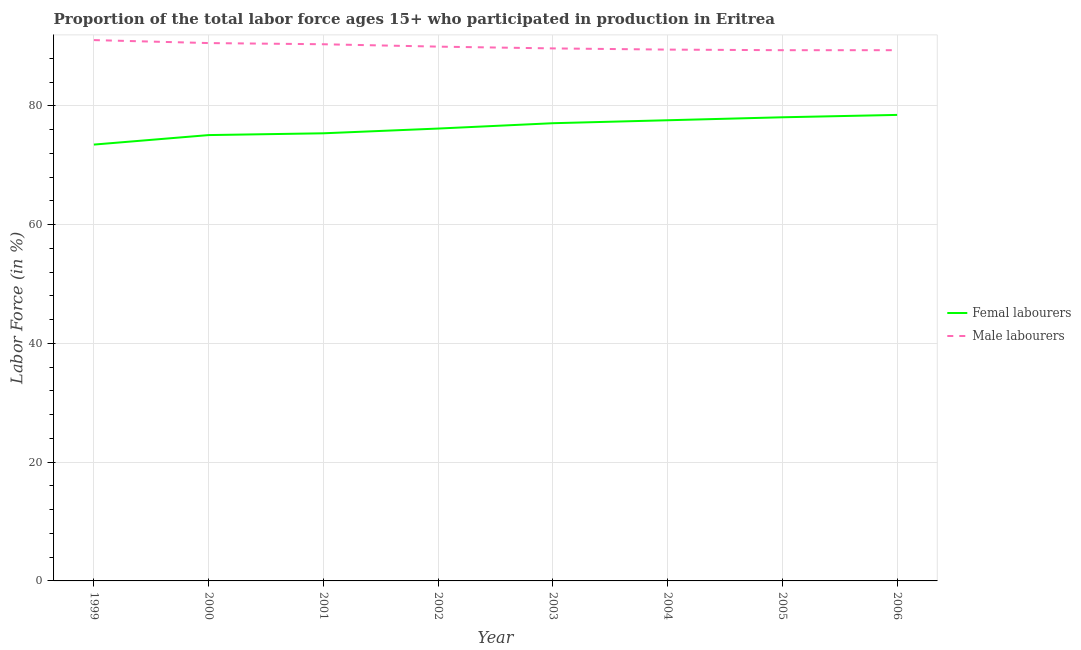How many different coloured lines are there?
Your response must be concise. 2. Does the line corresponding to percentage of female labor force intersect with the line corresponding to percentage of male labour force?
Provide a short and direct response. No. Is the number of lines equal to the number of legend labels?
Give a very brief answer. Yes. What is the percentage of female labor force in 2000?
Provide a short and direct response. 75.1. Across all years, what is the maximum percentage of female labor force?
Offer a very short reply. 78.5. Across all years, what is the minimum percentage of male labour force?
Provide a succinct answer. 89.4. What is the total percentage of male labour force in the graph?
Provide a succinct answer. 720.1. What is the difference between the percentage of female labor force in 2000 and that in 2001?
Provide a succinct answer. -0.3. What is the difference between the percentage of female labor force in 2004 and the percentage of male labour force in 2000?
Keep it short and to the point. -13. What is the average percentage of male labour force per year?
Keep it short and to the point. 90.01. In the year 2003, what is the difference between the percentage of female labor force and percentage of male labour force?
Give a very brief answer. -12.6. In how many years, is the percentage of male labour force greater than 80 %?
Make the answer very short. 8. What is the ratio of the percentage of female labor force in 1999 to that in 2000?
Provide a succinct answer. 0.98. Is the difference between the percentage of male labour force in 2001 and 2002 greater than the difference between the percentage of female labor force in 2001 and 2002?
Your response must be concise. Yes. What is the difference between the highest and the second highest percentage of female labor force?
Ensure brevity in your answer.  0.4. In how many years, is the percentage of female labor force greater than the average percentage of female labor force taken over all years?
Offer a terse response. 4. Is the sum of the percentage of male labour force in 1999 and 2006 greater than the maximum percentage of female labor force across all years?
Give a very brief answer. Yes. Is the percentage of male labour force strictly greater than the percentage of female labor force over the years?
Make the answer very short. Yes. How many years are there in the graph?
Offer a very short reply. 8. What is the difference between two consecutive major ticks on the Y-axis?
Provide a short and direct response. 20. Where does the legend appear in the graph?
Provide a succinct answer. Center right. What is the title of the graph?
Your response must be concise. Proportion of the total labor force ages 15+ who participated in production in Eritrea. Does "Foreign Liabilities" appear as one of the legend labels in the graph?
Make the answer very short. No. What is the label or title of the X-axis?
Offer a very short reply. Year. What is the Labor Force (in %) in Femal labourers in 1999?
Offer a very short reply. 73.5. What is the Labor Force (in %) of Male labourers in 1999?
Your answer should be compact. 91.1. What is the Labor Force (in %) in Femal labourers in 2000?
Keep it short and to the point. 75.1. What is the Labor Force (in %) in Male labourers in 2000?
Offer a terse response. 90.6. What is the Labor Force (in %) of Femal labourers in 2001?
Provide a short and direct response. 75.4. What is the Labor Force (in %) of Male labourers in 2001?
Give a very brief answer. 90.4. What is the Labor Force (in %) in Femal labourers in 2002?
Keep it short and to the point. 76.2. What is the Labor Force (in %) of Femal labourers in 2003?
Ensure brevity in your answer.  77.1. What is the Labor Force (in %) in Male labourers in 2003?
Provide a short and direct response. 89.7. What is the Labor Force (in %) of Femal labourers in 2004?
Make the answer very short. 77.6. What is the Labor Force (in %) of Male labourers in 2004?
Provide a succinct answer. 89.5. What is the Labor Force (in %) in Femal labourers in 2005?
Your response must be concise. 78.1. What is the Labor Force (in %) of Male labourers in 2005?
Provide a succinct answer. 89.4. What is the Labor Force (in %) of Femal labourers in 2006?
Provide a short and direct response. 78.5. What is the Labor Force (in %) in Male labourers in 2006?
Keep it short and to the point. 89.4. Across all years, what is the maximum Labor Force (in %) of Femal labourers?
Offer a terse response. 78.5. Across all years, what is the maximum Labor Force (in %) in Male labourers?
Your answer should be compact. 91.1. Across all years, what is the minimum Labor Force (in %) of Femal labourers?
Your answer should be compact. 73.5. Across all years, what is the minimum Labor Force (in %) of Male labourers?
Offer a very short reply. 89.4. What is the total Labor Force (in %) in Femal labourers in the graph?
Your answer should be very brief. 611.5. What is the total Labor Force (in %) in Male labourers in the graph?
Provide a succinct answer. 720.1. What is the difference between the Labor Force (in %) in Femal labourers in 1999 and that in 2000?
Offer a terse response. -1.6. What is the difference between the Labor Force (in %) of Male labourers in 1999 and that in 2001?
Your answer should be very brief. 0.7. What is the difference between the Labor Force (in %) in Male labourers in 1999 and that in 2002?
Give a very brief answer. 1.1. What is the difference between the Labor Force (in %) in Femal labourers in 1999 and that in 2003?
Ensure brevity in your answer.  -3.6. What is the difference between the Labor Force (in %) of Femal labourers in 1999 and that in 2004?
Ensure brevity in your answer.  -4.1. What is the difference between the Labor Force (in %) in Femal labourers in 2000 and that in 2001?
Keep it short and to the point. -0.3. What is the difference between the Labor Force (in %) in Femal labourers in 2000 and that in 2004?
Ensure brevity in your answer.  -2.5. What is the difference between the Labor Force (in %) in Male labourers in 2000 and that in 2004?
Your answer should be compact. 1.1. What is the difference between the Labor Force (in %) in Femal labourers in 2000 and that in 2005?
Make the answer very short. -3. What is the difference between the Labor Force (in %) in Femal labourers in 2000 and that in 2006?
Give a very brief answer. -3.4. What is the difference between the Labor Force (in %) of Male labourers in 2000 and that in 2006?
Provide a succinct answer. 1.2. What is the difference between the Labor Force (in %) in Femal labourers in 2001 and that in 2003?
Your answer should be compact. -1.7. What is the difference between the Labor Force (in %) of Male labourers in 2001 and that in 2005?
Provide a succinct answer. 1. What is the difference between the Labor Force (in %) in Femal labourers in 2001 and that in 2006?
Provide a succinct answer. -3.1. What is the difference between the Labor Force (in %) in Male labourers in 2002 and that in 2004?
Offer a very short reply. 0.5. What is the difference between the Labor Force (in %) in Femal labourers in 2002 and that in 2005?
Ensure brevity in your answer.  -1.9. What is the difference between the Labor Force (in %) in Femal labourers in 2002 and that in 2006?
Your answer should be compact. -2.3. What is the difference between the Labor Force (in %) of Femal labourers in 2003 and that in 2004?
Provide a succinct answer. -0.5. What is the difference between the Labor Force (in %) in Male labourers in 2003 and that in 2004?
Give a very brief answer. 0.2. What is the difference between the Labor Force (in %) of Femal labourers in 2003 and that in 2006?
Your response must be concise. -1.4. What is the difference between the Labor Force (in %) of Femal labourers in 2004 and that in 2006?
Make the answer very short. -0.9. What is the difference between the Labor Force (in %) of Male labourers in 2004 and that in 2006?
Keep it short and to the point. 0.1. What is the difference between the Labor Force (in %) of Femal labourers in 2005 and that in 2006?
Provide a succinct answer. -0.4. What is the difference between the Labor Force (in %) of Male labourers in 2005 and that in 2006?
Provide a short and direct response. 0. What is the difference between the Labor Force (in %) in Femal labourers in 1999 and the Labor Force (in %) in Male labourers in 2000?
Provide a short and direct response. -17.1. What is the difference between the Labor Force (in %) of Femal labourers in 1999 and the Labor Force (in %) of Male labourers in 2001?
Offer a terse response. -16.9. What is the difference between the Labor Force (in %) of Femal labourers in 1999 and the Labor Force (in %) of Male labourers in 2002?
Give a very brief answer. -16.5. What is the difference between the Labor Force (in %) in Femal labourers in 1999 and the Labor Force (in %) in Male labourers in 2003?
Offer a terse response. -16.2. What is the difference between the Labor Force (in %) of Femal labourers in 1999 and the Labor Force (in %) of Male labourers in 2004?
Make the answer very short. -16. What is the difference between the Labor Force (in %) in Femal labourers in 1999 and the Labor Force (in %) in Male labourers in 2005?
Your answer should be very brief. -15.9. What is the difference between the Labor Force (in %) of Femal labourers in 1999 and the Labor Force (in %) of Male labourers in 2006?
Give a very brief answer. -15.9. What is the difference between the Labor Force (in %) in Femal labourers in 2000 and the Labor Force (in %) in Male labourers in 2001?
Ensure brevity in your answer.  -15.3. What is the difference between the Labor Force (in %) in Femal labourers in 2000 and the Labor Force (in %) in Male labourers in 2002?
Offer a terse response. -14.9. What is the difference between the Labor Force (in %) of Femal labourers in 2000 and the Labor Force (in %) of Male labourers in 2003?
Make the answer very short. -14.6. What is the difference between the Labor Force (in %) of Femal labourers in 2000 and the Labor Force (in %) of Male labourers in 2004?
Keep it short and to the point. -14.4. What is the difference between the Labor Force (in %) in Femal labourers in 2000 and the Labor Force (in %) in Male labourers in 2005?
Your answer should be very brief. -14.3. What is the difference between the Labor Force (in %) of Femal labourers in 2000 and the Labor Force (in %) of Male labourers in 2006?
Ensure brevity in your answer.  -14.3. What is the difference between the Labor Force (in %) in Femal labourers in 2001 and the Labor Force (in %) in Male labourers in 2002?
Keep it short and to the point. -14.6. What is the difference between the Labor Force (in %) in Femal labourers in 2001 and the Labor Force (in %) in Male labourers in 2003?
Your answer should be very brief. -14.3. What is the difference between the Labor Force (in %) in Femal labourers in 2001 and the Labor Force (in %) in Male labourers in 2004?
Provide a short and direct response. -14.1. What is the difference between the Labor Force (in %) of Femal labourers in 2001 and the Labor Force (in %) of Male labourers in 2005?
Give a very brief answer. -14. What is the difference between the Labor Force (in %) of Femal labourers in 2002 and the Labor Force (in %) of Male labourers in 2004?
Keep it short and to the point. -13.3. What is the difference between the Labor Force (in %) of Femal labourers in 2002 and the Labor Force (in %) of Male labourers in 2006?
Provide a short and direct response. -13.2. What is the difference between the Labor Force (in %) in Femal labourers in 2003 and the Labor Force (in %) in Male labourers in 2004?
Your answer should be very brief. -12.4. What is the difference between the Labor Force (in %) of Femal labourers in 2004 and the Labor Force (in %) of Male labourers in 2005?
Offer a very short reply. -11.8. What is the difference between the Labor Force (in %) in Femal labourers in 2005 and the Labor Force (in %) in Male labourers in 2006?
Provide a short and direct response. -11.3. What is the average Labor Force (in %) in Femal labourers per year?
Your answer should be very brief. 76.44. What is the average Labor Force (in %) in Male labourers per year?
Provide a short and direct response. 90.01. In the year 1999, what is the difference between the Labor Force (in %) of Femal labourers and Labor Force (in %) of Male labourers?
Your answer should be compact. -17.6. In the year 2000, what is the difference between the Labor Force (in %) in Femal labourers and Labor Force (in %) in Male labourers?
Provide a succinct answer. -15.5. In the year 2001, what is the difference between the Labor Force (in %) in Femal labourers and Labor Force (in %) in Male labourers?
Your answer should be compact. -15. In the year 2002, what is the difference between the Labor Force (in %) in Femal labourers and Labor Force (in %) in Male labourers?
Give a very brief answer. -13.8. In the year 2003, what is the difference between the Labor Force (in %) in Femal labourers and Labor Force (in %) in Male labourers?
Make the answer very short. -12.6. In the year 2004, what is the difference between the Labor Force (in %) of Femal labourers and Labor Force (in %) of Male labourers?
Offer a very short reply. -11.9. What is the ratio of the Labor Force (in %) of Femal labourers in 1999 to that in 2000?
Offer a terse response. 0.98. What is the ratio of the Labor Force (in %) of Femal labourers in 1999 to that in 2001?
Offer a terse response. 0.97. What is the ratio of the Labor Force (in %) of Male labourers in 1999 to that in 2001?
Your answer should be compact. 1.01. What is the ratio of the Labor Force (in %) in Femal labourers in 1999 to that in 2002?
Keep it short and to the point. 0.96. What is the ratio of the Labor Force (in %) in Male labourers in 1999 to that in 2002?
Offer a very short reply. 1.01. What is the ratio of the Labor Force (in %) in Femal labourers in 1999 to that in 2003?
Provide a short and direct response. 0.95. What is the ratio of the Labor Force (in %) of Male labourers in 1999 to that in 2003?
Ensure brevity in your answer.  1.02. What is the ratio of the Labor Force (in %) in Femal labourers in 1999 to that in 2004?
Offer a terse response. 0.95. What is the ratio of the Labor Force (in %) of Male labourers in 1999 to that in 2004?
Keep it short and to the point. 1.02. What is the ratio of the Labor Force (in %) in Femal labourers in 1999 to that in 2005?
Your answer should be compact. 0.94. What is the ratio of the Labor Force (in %) in Femal labourers in 1999 to that in 2006?
Offer a terse response. 0.94. What is the ratio of the Labor Force (in %) of Femal labourers in 2000 to that in 2002?
Your answer should be very brief. 0.99. What is the ratio of the Labor Force (in %) in Male labourers in 2000 to that in 2002?
Your answer should be very brief. 1.01. What is the ratio of the Labor Force (in %) of Femal labourers in 2000 to that in 2003?
Offer a terse response. 0.97. What is the ratio of the Labor Force (in %) of Femal labourers in 2000 to that in 2004?
Give a very brief answer. 0.97. What is the ratio of the Labor Force (in %) of Male labourers in 2000 to that in 2004?
Ensure brevity in your answer.  1.01. What is the ratio of the Labor Force (in %) of Femal labourers in 2000 to that in 2005?
Offer a very short reply. 0.96. What is the ratio of the Labor Force (in %) in Male labourers in 2000 to that in 2005?
Your response must be concise. 1.01. What is the ratio of the Labor Force (in %) of Femal labourers in 2000 to that in 2006?
Offer a very short reply. 0.96. What is the ratio of the Labor Force (in %) of Male labourers in 2000 to that in 2006?
Keep it short and to the point. 1.01. What is the ratio of the Labor Force (in %) of Femal labourers in 2001 to that in 2002?
Your answer should be very brief. 0.99. What is the ratio of the Labor Force (in %) of Femal labourers in 2001 to that in 2004?
Keep it short and to the point. 0.97. What is the ratio of the Labor Force (in %) of Femal labourers in 2001 to that in 2005?
Your answer should be compact. 0.97. What is the ratio of the Labor Force (in %) in Male labourers in 2001 to that in 2005?
Give a very brief answer. 1.01. What is the ratio of the Labor Force (in %) of Femal labourers in 2001 to that in 2006?
Your answer should be very brief. 0.96. What is the ratio of the Labor Force (in %) of Male labourers in 2001 to that in 2006?
Give a very brief answer. 1.01. What is the ratio of the Labor Force (in %) of Femal labourers in 2002 to that in 2003?
Your answer should be compact. 0.99. What is the ratio of the Labor Force (in %) of Male labourers in 2002 to that in 2003?
Your answer should be very brief. 1. What is the ratio of the Labor Force (in %) of Male labourers in 2002 to that in 2004?
Your response must be concise. 1.01. What is the ratio of the Labor Force (in %) of Femal labourers in 2002 to that in 2005?
Provide a short and direct response. 0.98. What is the ratio of the Labor Force (in %) in Femal labourers in 2002 to that in 2006?
Your answer should be compact. 0.97. What is the ratio of the Labor Force (in %) of Femal labourers in 2003 to that in 2004?
Ensure brevity in your answer.  0.99. What is the ratio of the Labor Force (in %) in Male labourers in 2003 to that in 2004?
Provide a succinct answer. 1. What is the ratio of the Labor Force (in %) of Femal labourers in 2003 to that in 2005?
Give a very brief answer. 0.99. What is the ratio of the Labor Force (in %) of Male labourers in 2003 to that in 2005?
Your answer should be compact. 1. What is the ratio of the Labor Force (in %) of Femal labourers in 2003 to that in 2006?
Offer a very short reply. 0.98. What is the ratio of the Labor Force (in %) of Male labourers in 2004 to that in 2005?
Keep it short and to the point. 1. What is the ratio of the Labor Force (in %) of Femal labourers in 2005 to that in 2006?
Your answer should be compact. 0.99. What is the ratio of the Labor Force (in %) of Male labourers in 2005 to that in 2006?
Offer a terse response. 1. What is the difference between the highest and the second highest Labor Force (in %) in Femal labourers?
Ensure brevity in your answer.  0.4. What is the difference between the highest and the lowest Labor Force (in %) in Femal labourers?
Offer a terse response. 5. What is the difference between the highest and the lowest Labor Force (in %) in Male labourers?
Ensure brevity in your answer.  1.7. 